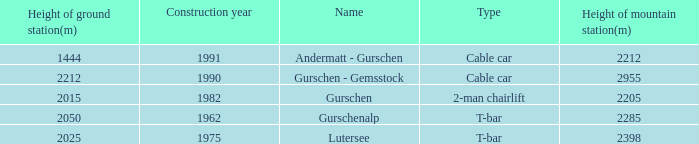How much Height of ground station(m) has a Name of lutersee, and a Height of mountain station(m) larger than 2398? 0.0. 